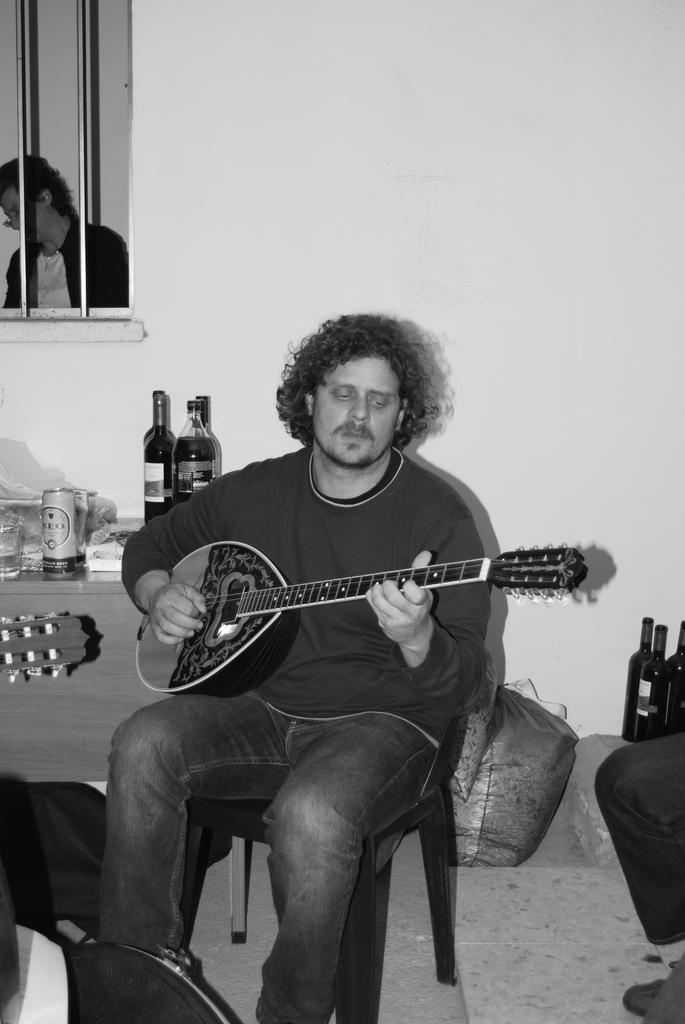What is the man in the middle of the image doing? The man is sitting in the middle of the image and playing a guitar. What is located behind the man? There is a wall behind the man. Can you describe any architectural features in the image? There is a window in the top left side of the image. What can be seen through the window? A person is visible through the window. What type of brick is being used to create the vase in the image? There is no vase present in the image, and therefore no brick can be associated with it. 